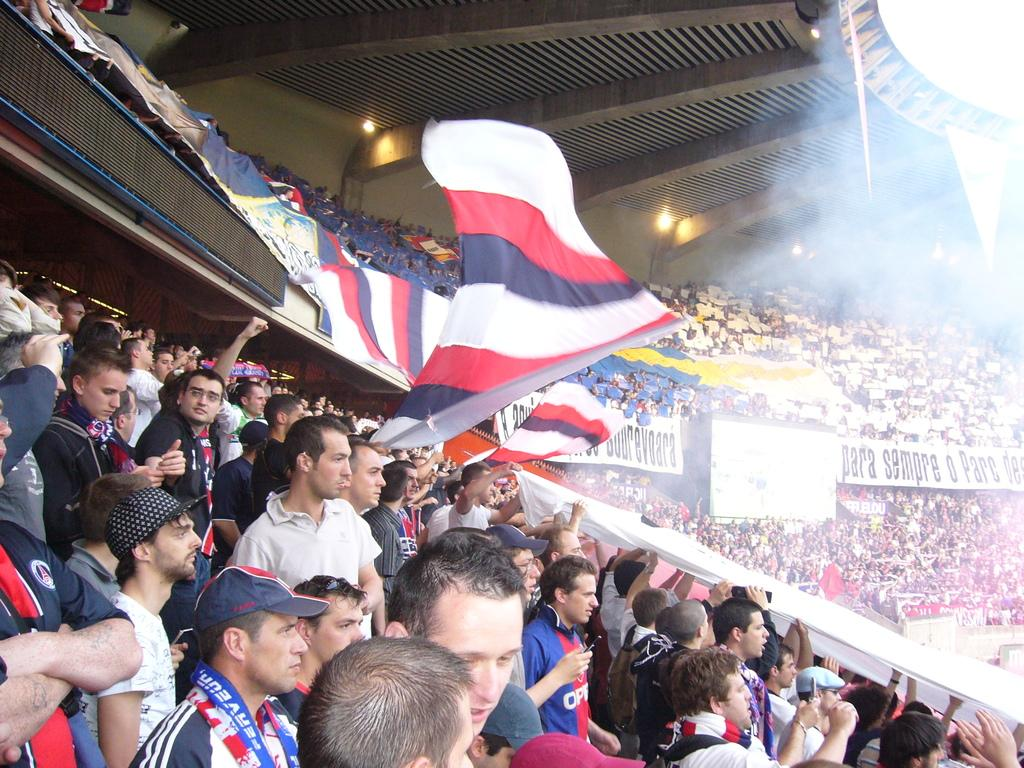What type of structure is visible in the image? There is a stadium in the image. How many people are present in the stadium? There are many people in the stadium. What are the people in the stadium doing? The people are looking at something. What type of wood is being used to build the oven in the image? There is no oven or wood present in the image; it features a stadium with many people. 